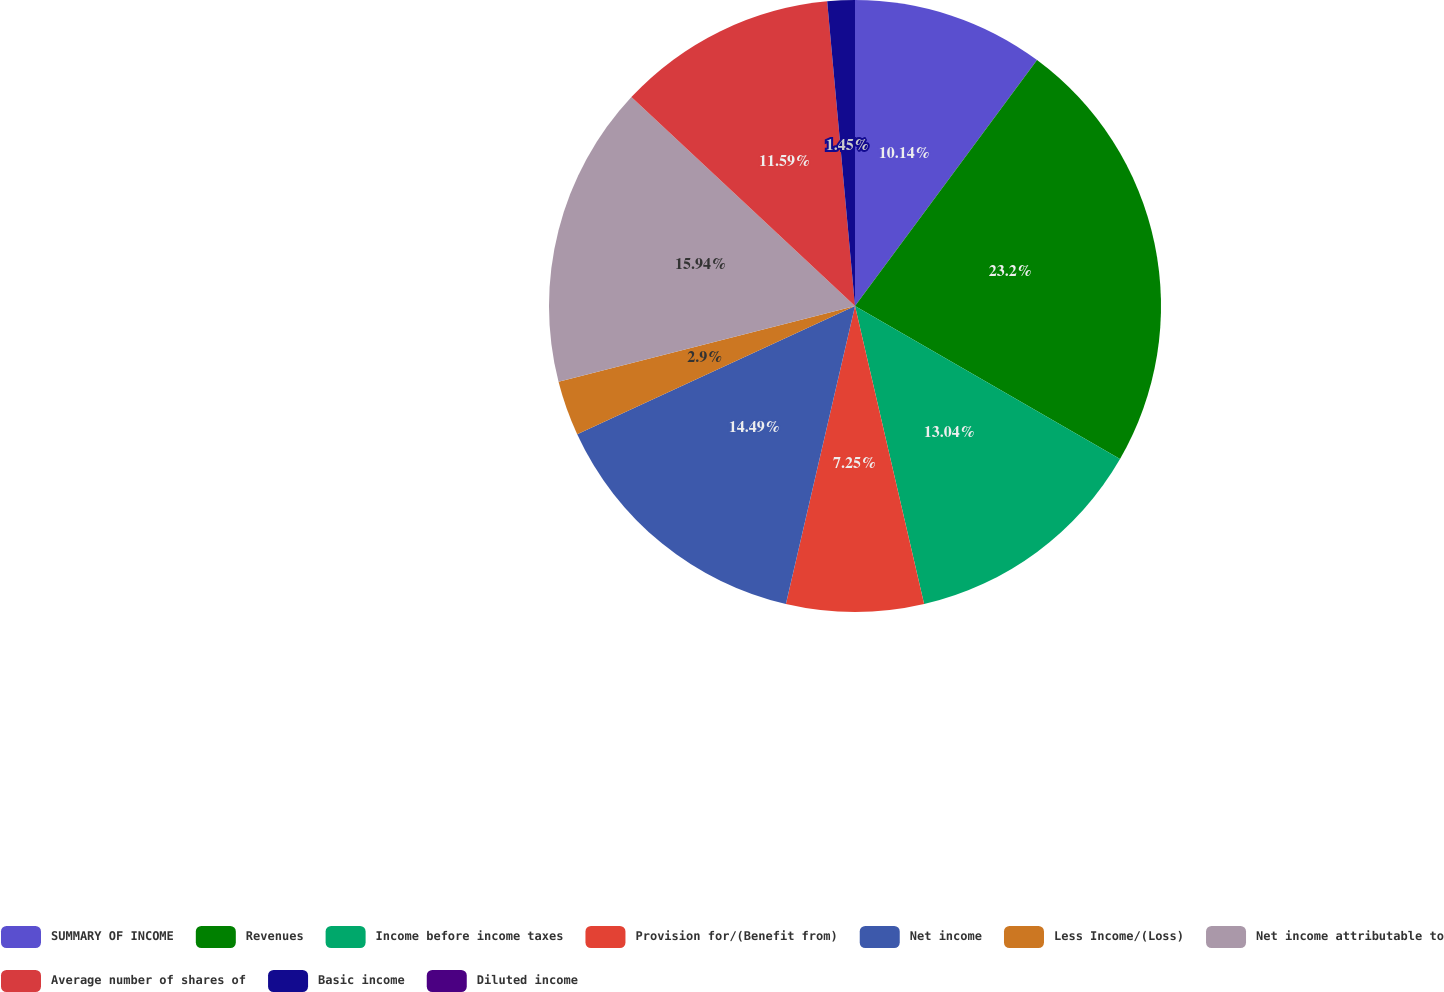<chart> <loc_0><loc_0><loc_500><loc_500><pie_chart><fcel>SUMMARY OF INCOME<fcel>Revenues<fcel>Income before income taxes<fcel>Provision for/(Benefit from)<fcel>Net income<fcel>Less Income/(Loss)<fcel>Net income attributable to<fcel>Average number of shares of<fcel>Basic income<fcel>Diluted income<nl><fcel>10.14%<fcel>23.19%<fcel>13.04%<fcel>7.25%<fcel>14.49%<fcel>2.9%<fcel>15.94%<fcel>11.59%<fcel>1.45%<fcel>0.0%<nl></chart> 